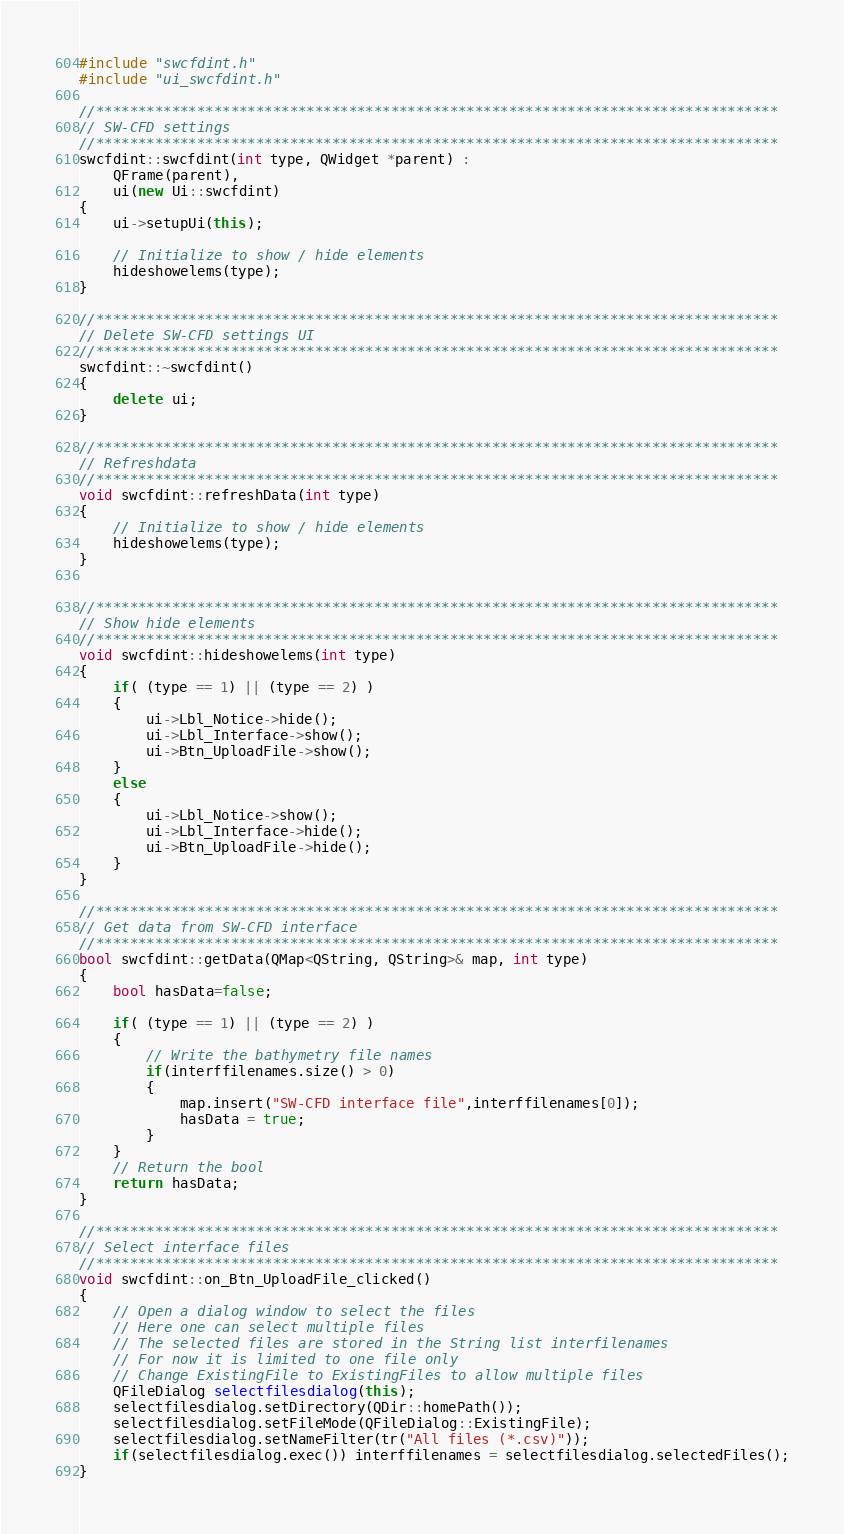<code> <loc_0><loc_0><loc_500><loc_500><_C++_>#include "swcfdint.h"
#include "ui_swcfdint.h"

//*********************************************************************************
// SW-CFD settings
//*********************************************************************************
swcfdint::swcfdint(int type, QWidget *parent) :
    QFrame(parent),
    ui(new Ui::swcfdint)
{
    ui->setupUi(this);

    // Initialize to show / hide elements
    hideshowelems(type);
}

//*********************************************************************************
// Delete SW-CFD settings UI
//*********************************************************************************
swcfdint::~swcfdint()
{
    delete ui;
}

//*********************************************************************************
// Refreshdata
//*********************************************************************************
void swcfdint::refreshData(int type)
{
    // Initialize to show / hide elements
    hideshowelems(type);
}


//*********************************************************************************
// Show hide elements
//*********************************************************************************
void swcfdint::hideshowelems(int type)
{
    if( (type == 1) || (type == 2) )
    {
        ui->Lbl_Notice->hide();
        ui->Lbl_Interface->show();
        ui->Btn_UploadFile->show();
    }
    else
    {
        ui->Lbl_Notice->show();
        ui->Lbl_Interface->hide();
        ui->Btn_UploadFile->hide();
    }
}

//*********************************************************************************
// Get data from SW-CFD interface
//*********************************************************************************
bool swcfdint::getData(QMap<QString, QString>& map, int type)
{
    bool hasData=false;

    if( (type == 1) || (type == 2) )
    {
        // Write the bathymetry file names
        if(interffilenames.size() > 0)
        {
            map.insert("SW-CFD interface file",interffilenames[0]);
            hasData = true;
        }
    }
    // Return the bool
    return hasData;
}

//*********************************************************************************
// Select interface files
//*********************************************************************************
void swcfdint::on_Btn_UploadFile_clicked()
{
    // Open a dialog window to select the files
    // Here one can select multiple files
    // The selected files are stored in the String list interfilenames
    // For now it is limited to one file only
    // Change ExistingFile to ExistingFiles to allow multiple files
    QFileDialog selectfilesdialog(this);
    selectfilesdialog.setDirectory(QDir::homePath());
    selectfilesdialog.setFileMode(QFileDialog::ExistingFile);
    selectfilesdialog.setNameFilter(tr("All files (*.csv)"));
    if(selectfilesdialog.exec()) interffilenames = selectfilesdialog.selectedFiles();
}
</code> 